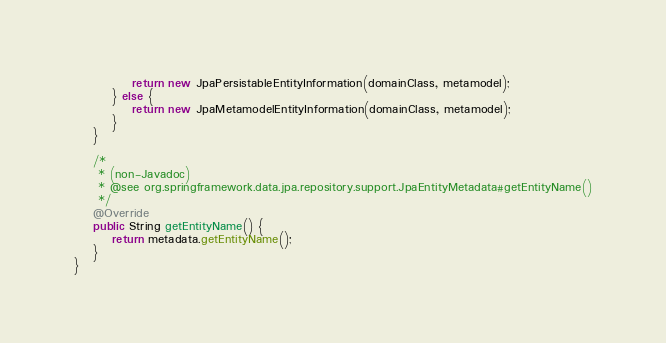Convert code to text. <code><loc_0><loc_0><loc_500><loc_500><_Java_>			return new JpaPersistableEntityInformation(domainClass, metamodel);
		} else {
			return new JpaMetamodelEntityInformation(domainClass, metamodel);
		}
	}

	/*
	 * (non-Javadoc)
	 * @see org.springframework.data.jpa.repository.support.JpaEntityMetadata#getEntityName()
	 */
	@Override
	public String getEntityName() {
		return metadata.getEntityName();
	}
}
</code> 